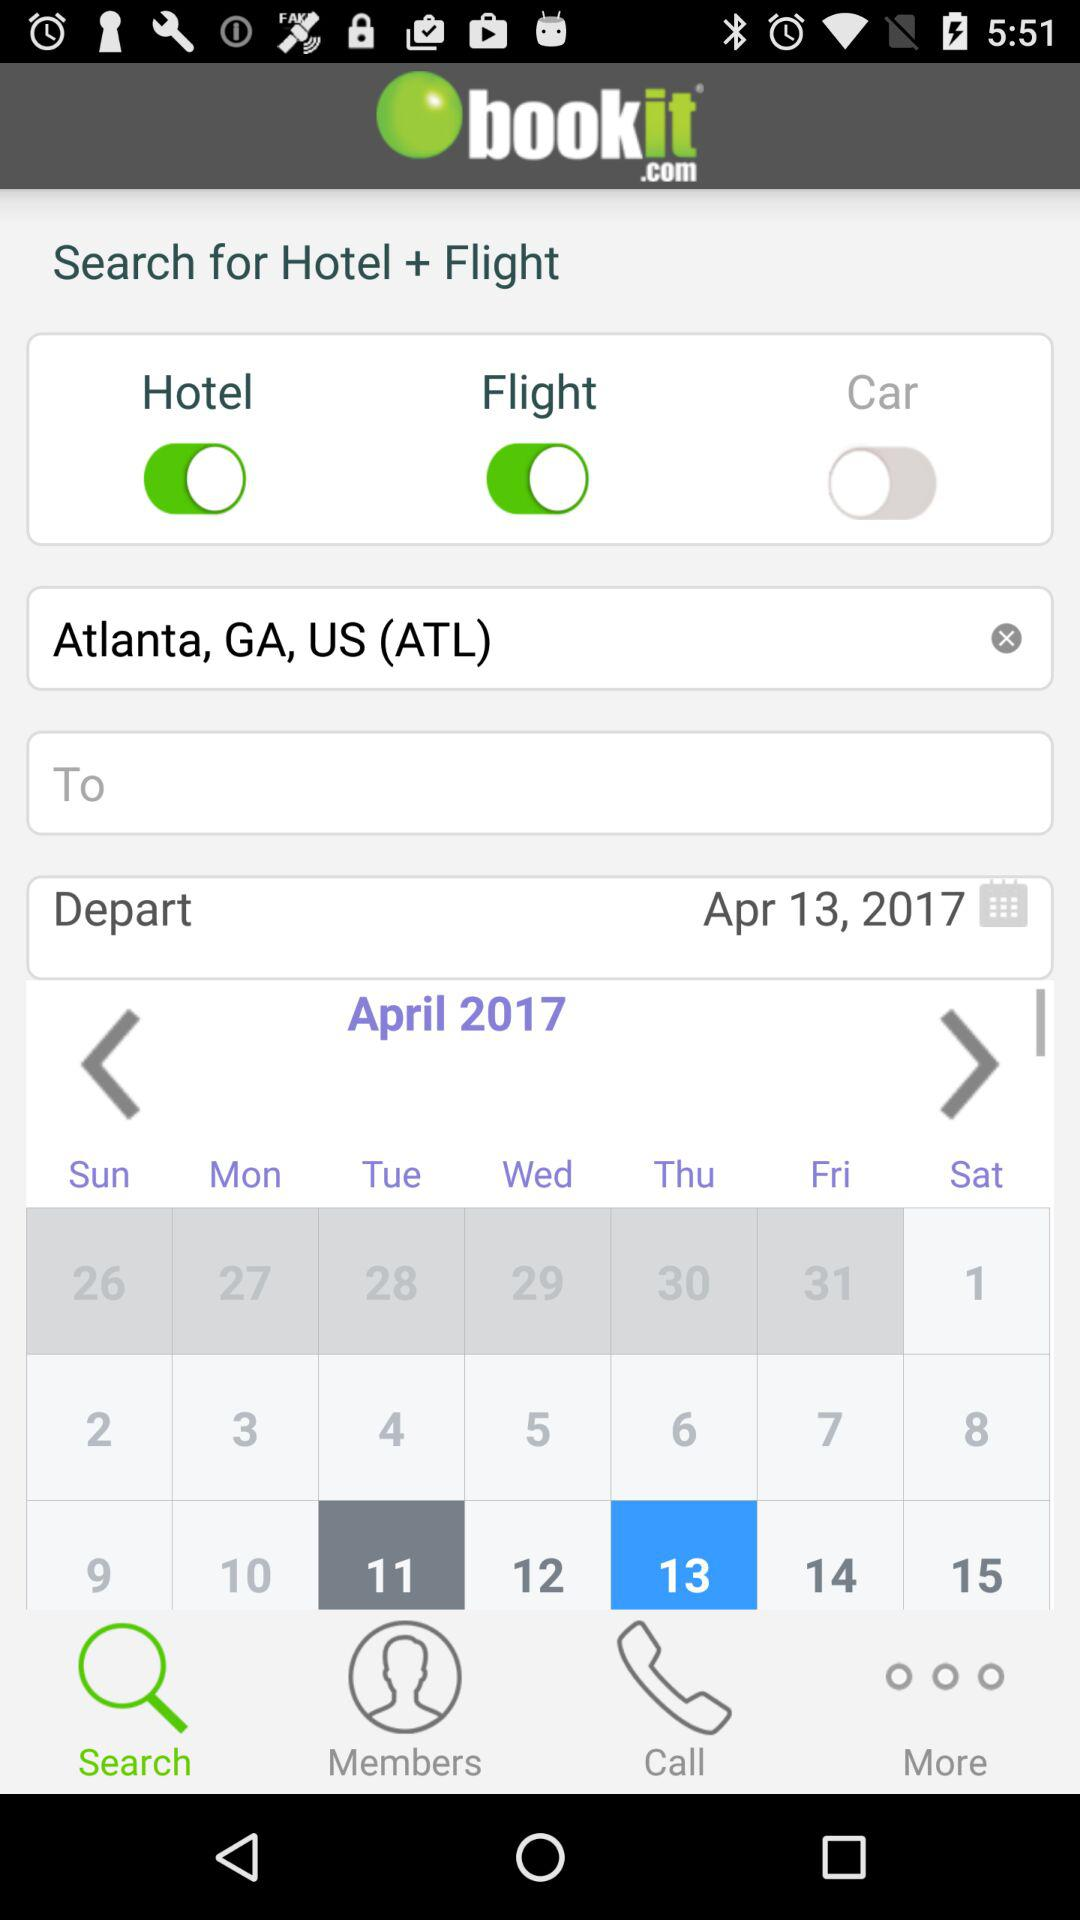Which tab is selected? The selected tab is "Search". 